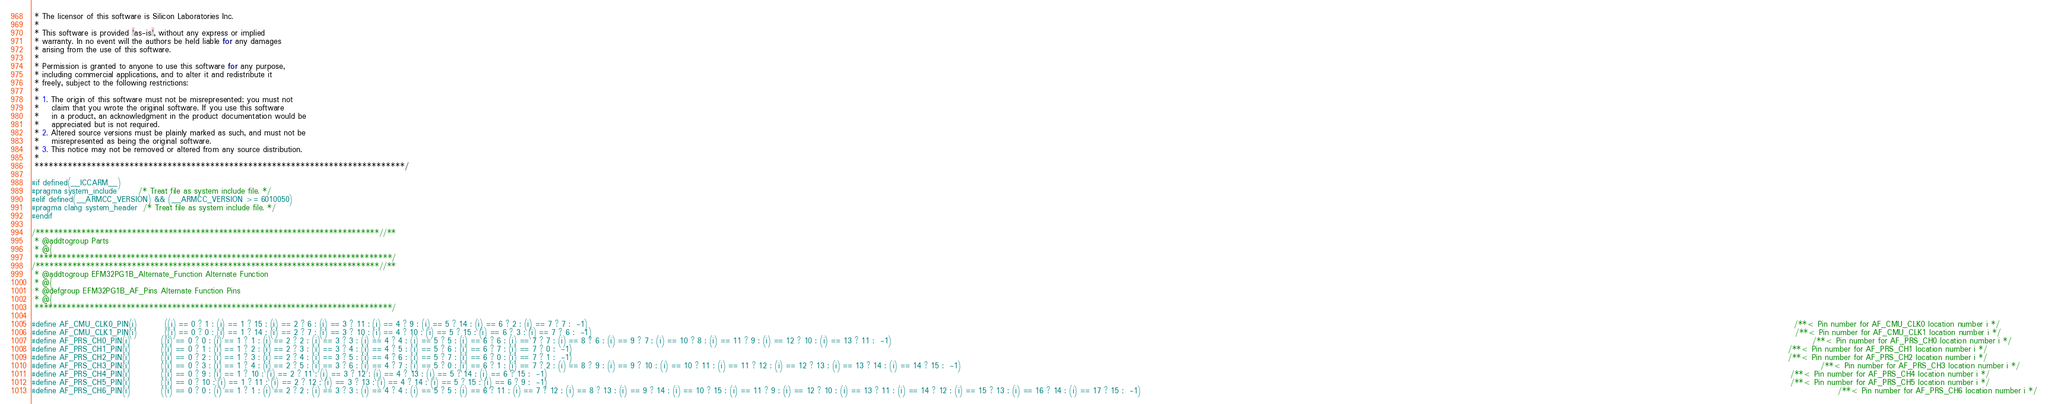<code> <loc_0><loc_0><loc_500><loc_500><_C_> * The licensor of this software is Silicon Laboratories Inc.
 *
 * This software is provided 'as-is', without any express or implied
 * warranty. In no event will the authors be held liable for any damages
 * arising from the use of this software.
 *
 * Permission is granted to anyone to use this software for any purpose,
 * including commercial applications, and to alter it and redistribute it
 * freely, subject to the following restrictions:
 *
 * 1. The origin of this software must not be misrepresented; you must not
 *    claim that you wrote the original software. If you use this software
 *    in a product, an acknowledgment in the product documentation would be
 *    appreciated but is not required.
 * 2. Altered source versions must be plainly marked as such, and must not be
 *    misrepresented as being the original software.
 * 3. This notice may not be removed or altered from any source distribution.
 *
 ******************************************************************************/

#if defined(__ICCARM__)
#pragma system_include       /* Treat file as system include file. */
#elif defined(__ARMCC_VERSION) && (__ARMCC_VERSION >= 6010050)
#pragma clang system_header  /* Treat file as system include file. */
#endif

/***************************************************************************//**
 * @addtogroup Parts
 * @{
 ******************************************************************************/
/***************************************************************************//**
 * @addtogroup EFM32PG1B_Alternate_Function Alternate Function
 * @{
 * @defgroup EFM32PG1B_AF_Pins Alternate Function Pins
 * @{
 ******************************************************************************/

#define AF_CMU_CLK0_PIN(i)         ((i) == 0 ? 1 : (i) == 1 ? 15 : (i) == 2 ? 6 : (i) == 3 ? 11 : (i) == 4 ? 9 : (i) == 5 ? 14 : (i) == 6 ? 2 : (i) == 7 ? 7 :  -1)                                                                                                                                                                                                                                                                                                                                                                                                         /**< Pin number for AF_CMU_CLK0 location number i */
#define AF_CMU_CLK1_PIN(i)         ((i) == 0 ? 0 : (i) == 1 ? 14 : (i) == 2 ? 7 : (i) == 3 ? 10 : (i) == 4 ? 10 : (i) == 5 ? 15 : (i) == 6 ? 3 : (i) == 7 ? 6 :  -1)                                                                                                                                                                                                                                                                                                                                                                                                        /**< Pin number for AF_CMU_CLK1 location number i */
#define AF_PRS_CH0_PIN(i)          ((i) == 0 ? 0 : (i) == 1 ? 1 : (i) == 2 ? 2 : (i) == 3 ? 3 : (i) == 4 ? 4 : (i) == 5 ? 5 : (i) == 6 ? 6 : (i) == 7 ? 7 : (i) == 8 ? 6 : (i) == 9 ? 7 : (i) == 10 ? 8 : (i) == 11 ? 9 : (i) == 12 ? 10 : (i) == 13 ? 11 :  -1)                                                                                                                                                                                                                                                                                                            /**< Pin number for AF_PRS_CH0 location number i */
#define AF_PRS_CH1_PIN(i)          ((i) == 0 ? 1 : (i) == 1 ? 2 : (i) == 2 ? 3 : (i) == 3 ? 4 : (i) == 4 ? 5 : (i) == 5 ? 6 : (i) == 6 ? 7 : (i) == 7 ? 0 :  -1)                                                                                                                                                                                                                                                                                                                                                                                                            /**< Pin number for AF_PRS_CH1 location number i */
#define AF_PRS_CH2_PIN(i)          ((i) == 0 ? 2 : (i) == 1 ? 3 : (i) == 2 ? 4 : (i) == 3 ? 5 : (i) == 4 ? 6 : (i) == 5 ? 7 : (i) == 6 ? 0 : (i) == 7 ? 1 :  -1)                                                                                                                                                                                                                                                                                                                                                                                                            /**< Pin number for AF_PRS_CH2 location number i */
#define AF_PRS_CH3_PIN(i)          ((i) == 0 ? 3 : (i) == 1 ? 4 : (i) == 2 ? 5 : (i) == 3 ? 6 : (i) == 4 ? 7 : (i) == 5 ? 0 : (i) == 6 ? 1 : (i) == 7 ? 2 : (i) == 8 ? 9 : (i) == 9 ? 10 : (i) == 10 ? 11 : (i) == 11 ? 12 : (i) == 12 ? 13 : (i) == 13 ? 14 : (i) == 14 ? 15 :  -1)                                                                                                                                                                                                                                                                                        /**< Pin number for AF_PRS_CH3 location number i */
#define AF_PRS_CH4_PIN(i)          ((i) == 0 ? 9 : (i) == 1 ? 10 : (i) == 2 ? 11 : (i) == 3 ? 12 : (i) == 4 ? 13 : (i) == 5 ? 14 : (i) == 6 ? 15 :  -1)                                                                                                                                                                                                                                                                                                                                                                                                                     /**< Pin number for AF_PRS_CH4 location number i */
#define AF_PRS_CH5_PIN(i)          ((i) == 0 ? 10 : (i) == 1 ? 11 : (i) == 2 ? 12 : (i) == 3 ? 13 : (i) == 4 ? 14 : (i) == 5 ? 15 : (i) == 6 ? 9 :  -1)                                                                                                                                                                                                                                                                                                                                                                                                                     /**< Pin number for AF_PRS_CH5 location number i */
#define AF_PRS_CH6_PIN(i)          ((i) == 0 ? 0 : (i) == 1 ? 1 : (i) == 2 ? 2 : (i) == 3 ? 3 : (i) == 4 ? 4 : (i) == 5 ? 5 : (i) == 6 ? 11 : (i) == 7 ? 12 : (i) == 8 ? 13 : (i) == 9 ? 14 : (i) == 10 ? 15 : (i) == 11 ? 9 : (i) == 12 ? 10 : (i) == 13 ? 11 : (i) == 14 ? 12 : (i) == 15 ? 13 : (i) == 16 ? 14 : (i) == 17 ? 15 :  -1)                                                                                                                                                                                                                                   /**< Pin number for AF_PRS_CH6 location number i */</code> 